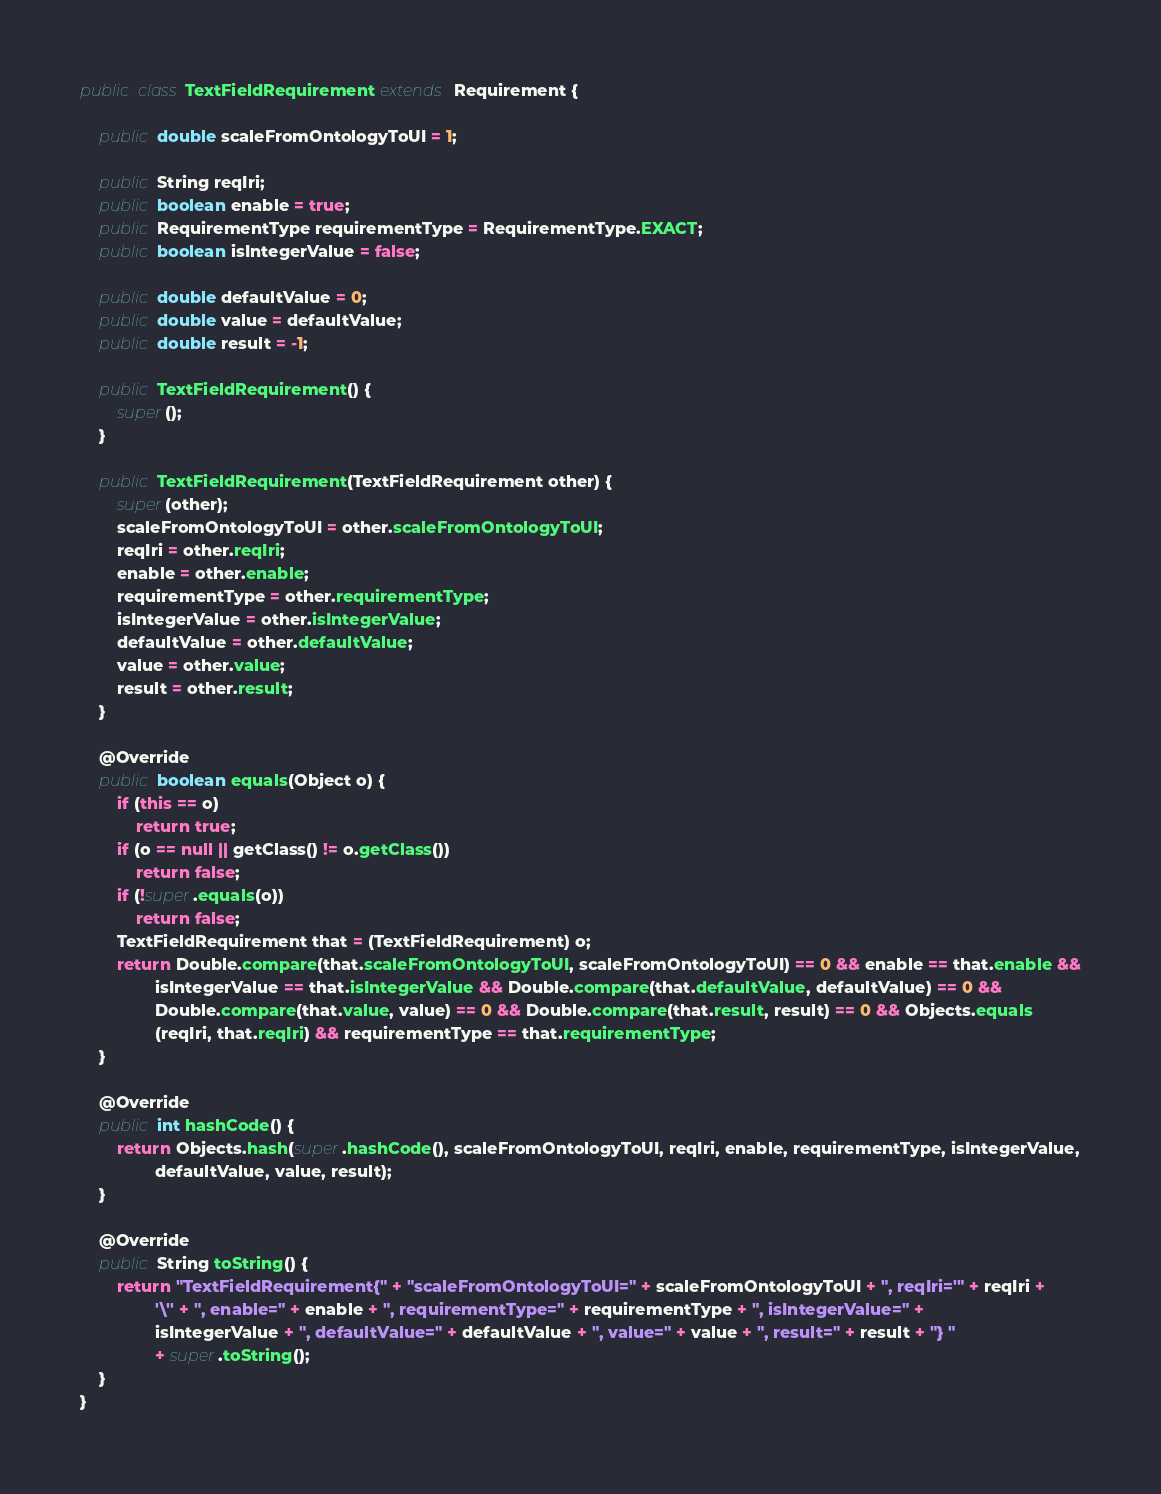Convert code to text. <code><loc_0><loc_0><loc_500><loc_500><_Java_>public class TextFieldRequirement extends Requirement {

    public double scaleFromOntologyToUI = 1;

    public String reqIri;
    public boolean enable = true;
    public RequirementType requirementType = RequirementType.EXACT;
    public boolean isIntegerValue = false;

    public double defaultValue = 0;
    public double value = defaultValue;
    public double result = -1;

    public TextFieldRequirement() {
        super();
    }

    public TextFieldRequirement(TextFieldRequirement other) {
        super(other);
        scaleFromOntologyToUI = other.scaleFromOntologyToUI;
        reqIri = other.reqIri;
        enable = other.enable;
        requirementType = other.requirementType;
        isIntegerValue = other.isIntegerValue;
        defaultValue = other.defaultValue;
        value = other.value;
        result = other.result;
    }

    @Override
    public boolean equals(Object o) {
        if (this == o)
            return true;
        if (o == null || getClass() != o.getClass())
            return false;
        if (!super.equals(o))
            return false;
        TextFieldRequirement that = (TextFieldRequirement) o;
        return Double.compare(that.scaleFromOntologyToUI, scaleFromOntologyToUI) == 0 && enable == that.enable &&
                isIntegerValue == that.isIntegerValue && Double.compare(that.defaultValue, defaultValue) == 0 &&
                Double.compare(that.value, value) == 0 && Double.compare(that.result, result) == 0 && Objects.equals
                (reqIri, that.reqIri) && requirementType == that.requirementType;
    }

    @Override
    public int hashCode() {
        return Objects.hash(super.hashCode(), scaleFromOntologyToUI, reqIri, enable, requirementType, isIntegerValue,
                defaultValue, value, result);
    }

    @Override
    public String toString() {
        return "TextFieldRequirement{" + "scaleFromOntologyToUI=" + scaleFromOntologyToUI + ", reqIri='" + reqIri +
                '\'' + ", enable=" + enable + ", requirementType=" + requirementType + ", isIntegerValue=" +
                isIntegerValue + ", defaultValue=" + defaultValue + ", value=" + value + ", result=" + result + "} "
                + super.toString();
    }
}
</code> 